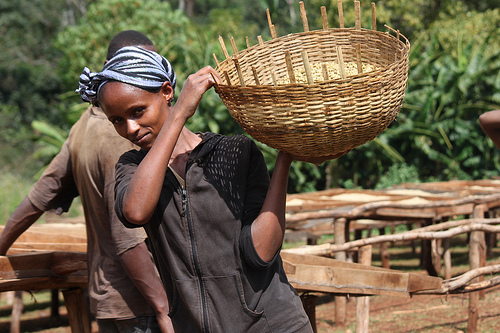<image>
Is there a lady behind the basket? No. The lady is not behind the basket. From this viewpoint, the lady appears to be positioned elsewhere in the scene. 